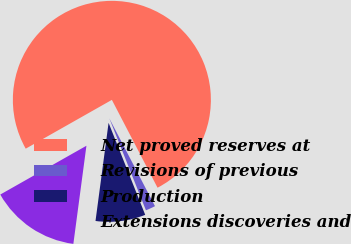Convert chart. <chart><loc_0><loc_0><loc_500><loc_500><pie_chart><fcel>Net proved reserves at<fcel>Revisions of previous<fcel>Production<fcel>Extensions discoveries and<nl><fcel>75.58%<fcel>1.6%<fcel>8.14%<fcel>14.69%<nl></chart> 